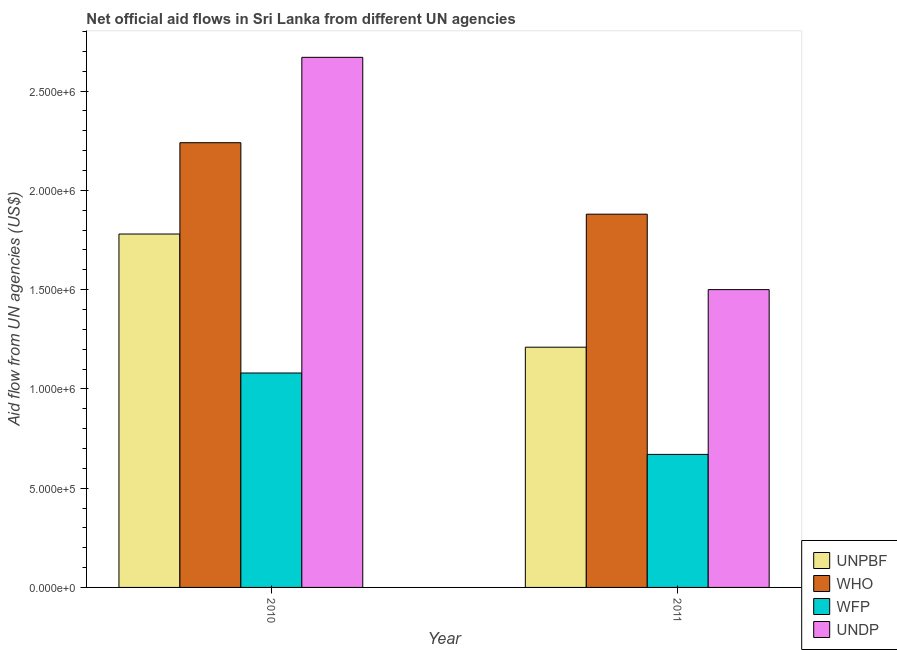How many different coloured bars are there?
Ensure brevity in your answer.  4. Are the number of bars per tick equal to the number of legend labels?
Your response must be concise. Yes. How many bars are there on the 1st tick from the right?
Provide a succinct answer. 4. What is the label of the 2nd group of bars from the left?
Give a very brief answer. 2011. In how many cases, is the number of bars for a given year not equal to the number of legend labels?
Your answer should be very brief. 0. What is the amount of aid given by who in 2011?
Your response must be concise. 1.88e+06. Across all years, what is the maximum amount of aid given by undp?
Offer a very short reply. 2.67e+06. Across all years, what is the minimum amount of aid given by unpbf?
Your answer should be very brief. 1.21e+06. In which year was the amount of aid given by undp minimum?
Keep it short and to the point. 2011. What is the total amount of aid given by unpbf in the graph?
Keep it short and to the point. 2.99e+06. What is the difference between the amount of aid given by wfp in 2010 and that in 2011?
Keep it short and to the point. 4.10e+05. What is the difference between the amount of aid given by wfp in 2010 and the amount of aid given by unpbf in 2011?
Make the answer very short. 4.10e+05. What is the average amount of aid given by unpbf per year?
Make the answer very short. 1.50e+06. In how many years, is the amount of aid given by unpbf greater than 1200000 US$?
Provide a short and direct response. 2. What is the ratio of the amount of aid given by undp in 2010 to that in 2011?
Your answer should be very brief. 1.78. In how many years, is the amount of aid given by who greater than the average amount of aid given by who taken over all years?
Ensure brevity in your answer.  1. What does the 2nd bar from the left in 2011 represents?
Provide a short and direct response. WHO. What does the 3rd bar from the right in 2011 represents?
Your answer should be very brief. WHO. Are the values on the major ticks of Y-axis written in scientific E-notation?
Your answer should be compact. Yes. Does the graph contain grids?
Provide a succinct answer. No. Where does the legend appear in the graph?
Provide a succinct answer. Bottom right. How are the legend labels stacked?
Keep it short and to the point. Vertical. What is the title of the graph?
Offer a very short reply. Net official aid flows in Sri Lanka from different UN agencies. Does "Switzerland" appear as one of the legend labels in the graph?
Provide a succinct answer. No. What is the label or title of the Y-axis?
Your answer should be compact. Aid flow from UN agencies (US$). What is the Aid flow from UN agencies (US$) of UNPBF in 2010?
Provide a short and direct response. 1.78e+06. What is the Aid flow from UN agencies (US$) in WHO in 2010?
Offer a terse response. 2.24e+06. What is the Aid flow from UN agencies (US$) of WFP in 2010?
Give a very brief answer. 1.08e+06. What is the Aid flow from UN agencies (US$) of UNDP in 2010?
Ensure brevity in your answer.  2.67e+06. What is the Aid flow from UN agencies (US$) of UNPBF in 2011?
Your answer should be very brief. 1.21e+06. What is the Aid flow from UN agencies (US$) in WHO in 2011?
Provide a succinct answer. 1.88e+06. What is the Aid flow from UN agencies (US$) in WFP in 2011?
Your answer should be compact. 6.70e+05. What is the Aid flow from UN agencies (US$) of UNDP in 2011?
Provide a short and direct response. 1.50e+06. Across all years, what is the maximum Aid flow from UN agencies (US$) of UNPBF?
Offer a very short reply. 1.78e+06. Across all years, what is the maximum Aid flow from UN agencies (US$) of WHO?
Offer a terse response. 2.24e+06. Across all years, what is the maximum Aid flow from UN agencies (US$) in WFP?
Ensure brevity in your answer.  1.08e+06. Across all years, what is the maximum Aid flow from UN agencies (US$) of UNDP?
Ensure brevity in your answer.  2.67e+06. Across all years, what is the minimum Aid flow from UN agencies (US$) in UNPBF?
Your answer should be compact. 1.21e+06. Across all years, what is the minimum Aid flow from UN agencies (US$) of WHO?
Offer a terse response. 1.88e+06. Across all years, what is the minimum Aid flow from UN agencies (US$) in WFP?
Your answer should be very brief. 6.70e+05. Across all years, what is the minimum Aid flow from UN agencies (US$) in UNDP?
Your answer should be very brief. 1.50e+06. What is the total Aid flow from UN agencies (US$) in UNPBF in the graph?
Your answer should be compact. 2.99e+06. What is the total Aid flow from UN agencies (US$) in WHO in the graph?
Give a very brief answer. 4.12e+06. What is the total Aid flow from UN agencies (US$) in WFP in the graph?
Make the answer very short. 1.75e+06. What is the total Aid flow from UN agencies (US$) of UNDP in the graph?
Provide a succinct answer. 4.17e+06. What is the difference between the Aid flow from UN agencies (US$) in UNPBF in 2010 and that in 2011?
Make the answer very short. 5.70e+05. What is the difference between the Aid flow from UN agencies (US$) in WFP in 2010 and that in 2011?
Provide a short and direct response. 4.10e+05. What is the difference between the Aid flow from UN agencies (US$) of UNDP in 2010 and that in 2011?
Give a very brief answer. 1.17e+06. What is the difference between the Aid flow from UN agencies (US$) in UNPBF in 2010 and the Aid flow from UN agencies (US$) in WHO in 2011?
Ensure brevity in your answer.  -1.00e+05. What is the difference between the Aid flow from UN agencies (US$) of UNPBF in 2010 and the Aid flow from UN agencies (US$) of WFP in 2011?
Give a very brief answer. 1.11e+06. What is the difference between the Aid flow from UN agencies (US$) in WHO in 2010 and the Aid flow from UN agencies (US$) in WFP in 2011?
Make the answer very short. 1.57e+06. What is the difference between the Aid flow from UN agencies (US$) in WHO in 2010 and the Aid flow from UN agencies (US$) in UNDP in 2011?
Ensure brevity in your answer.  7.40e+05. What is the difference between the Aid flow from UN agencies (US$) of WFP in 2010 and the Aid flow from UN agencies (US$) of UNDP in 2011?
Provide a short and direct response. -4.20e+05. What is the average Aid flow from UN agencies (US$) in UNPBF per year?
Provide a short and direct response. 1.50e+06. What is the average Aid flow from UN agencies (US$) in WHO per year?
Ensure brevity in your answer.  2.06e+06. What is the average Aid flow from UN agencies (US$) in WFP per year?
Your answer should be compact. 8.75e+05. What is the average Aid flow from UN agencies (US$) of UNDP per year?
Your response must be concise. 2.08e+06. In the year 2010, what is the difference between the Aid flow from UN agencies (US$) in UNPBF and Aid flow from UN agencies (US$) in WHO?
Your answer should be very brief. -4.60e+05. In the year 2010, what is the difference between the Aid flow from UN agencies (US$) in UNPBF and Aid flow from UN agencies (US$) in UNDP?
Make the answer very short. -8.90e+05. In the year 2010, what is the difference between the Aid flow from UN agencies (US$) of WHO and Aid flow from UN agencies (US$) of WFP?
Provide a succinct answer. 1.16e+06. In the year 2010, what is the difference between the Aid flow from UN agencies (US$) of WHO and Aid flow from UN agencies (US$) of UNDP?
Provide a succinct answer. -4.30e+05. In the year 2010, what is the difference between the Aid flow from UN agencies (US$) in WFP and Aid flow from UN agencies (US$) in UNDP?
Your answer should be compact. -1.59e+06. In the year 2011, what is the difference between the Aid flow from UN agencies (US$) of UNPBF and Aid flow from UN agencies (US$) of WHO?
Ensure brevity in your answer.  -6.70e+05. In the year 2011, what is the difference between the Aid flow from UN agencies (US$) in UNPBF and Aid flow from UN agencies (US$) in WFP?
Make the answer very short. 5.40e+05. In the year 2011, what is the difference between the Aid flow from UN agencies (US$) of UNPBF and Aid flow from UN agencies (US$) of UNDP?
Provide a succinct answer. -2.90e+05. In the year 2011, what is the difference between the Aid flow from UN agencies (US$) in WHO and Aid flow from UN agencies (US$) in WFP?
Your answer should be very brief. 1.21e+06. In the year 2011, what is the difference between the Aid flow from UN agencies (US$) in WFP and Aid flow from UN agencies (US$) in UNDP?
Offer a very short reply. -8.30e+05. What is the ratio of the Aid flow from UN agencies (US$) of UNPBF in 2010 to that in 2011?
Offer a very short reply. 1.47. What is the ratio of the Aid flow from UN agencies (US$) in WHO in 2010 to that in 2011?
Keep it short and to the point. 1.19. What is the ratio of the Aid flow from UN agencies (US$) of WFP in 2010 to that in 2011?
Your answer should be very brief. 1.61. What is the ratio of the Aid flow from UN agencies (US$) in UNDP in 2010 to that in 2011?
Your answer should be compact. 1.78. What is the difference between the highest and the second highest Aid flow from UN agencies (US$) in UNPBF?
Your answer should be compact. 5.70e+05. What is the difference between the highest and the second highest Aid flow from UN agencies (US$) of WHO?
Give a very brief answer. 3.60e+05. What is the difference between the highest and the second highest Aid flow from UN agencies (US$) in WFP?
Your answer should be very brief. 4.10e+05. What is the difference between the highest and the second highest Aid flow from UN agencies (US$) in UNDP?
Keep it short and to the point. 1.17e+06. What is the difference between the highest and the lowest Aid flow from UN agencies (US$) in UNPBF?
Make the answer very short. 5.70e+05. What is the difference between the highest and the lowest Aid flow from UN agencies (US$) in WHO?
Keep it short and to the point. 3.60e+05. What is the difference between the highest and the lowest Aid flow from UN agencies (US$) in WFP?
Give a very brief answer. 4.10e+05. What is the difference between the highest and the lowest Aid flow from UN agencies (US$) of UNDP?
Your answer should be very brief. 1.17e+06. 